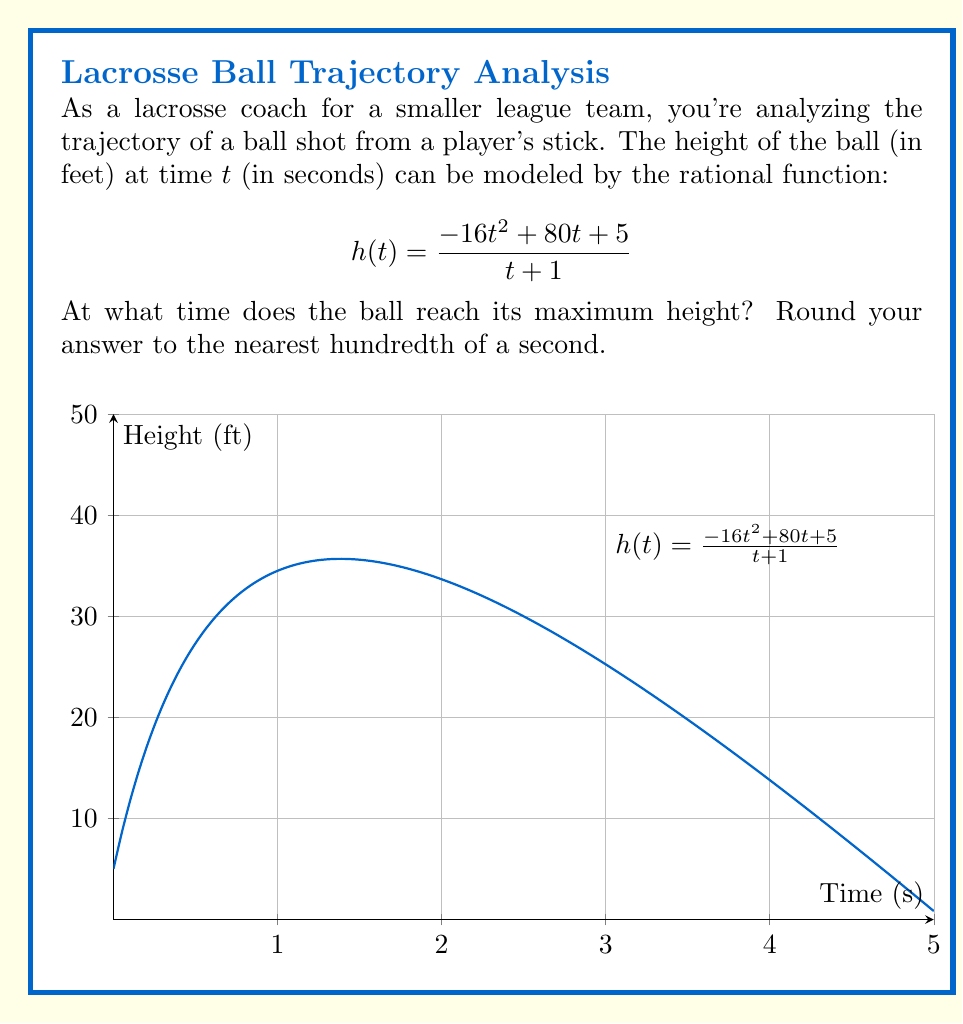Solve this math problem. To find the maximum height of the ball, we need to determine where the derivative of h(t) equals zero.

1) First, let's find h'(t) using the quotient rule:
   $$h'(t) = \frac{(-32t + 80)(t + 1) - (-16t^2 + 80t + 5)(1)}{(t + 1)^2}$$

2) Simplify the numerator:
   $$h'(t) = \frac{-32t^2 - 32t + 80t + 80 + 16t^2 - 80t - 5}{(t + 1)^2}$$
   $$h'(t) = \frac{-16t^2 + 48t + 75}{(t + 1)^2}$$

3) Set h'(t) = 0 and solve for t:
   $$\frac{-16t^2 + 48t + 75}{(t + 1)^2} = 0$$

4) The denominator is always positive for real t, so we only need to solve:
   $$-16t^2 + 48t + 75 = 0$$

5) This is a quadratic equation. We can solve it using the quadratic formula:
   $$t = \frac{-b \pm \sqrt{b^2 - 4ac}}{2a}$$
   Where a = -16, b = 48, and c = 75

6) Plugging in these values:
   $$t = \frac{-48 \pm \sqrt{48^2 - 4(-16)(75)}}{2(-16)}$$
   $$t = \frac{-48 \pm \sqrt{2304 + 4800}}{-32}$$
   $$t = \frac{-48 \pm \sqrt{7104}}{-32}$$
   $$t = \frac{-48 \pm 84.28}{-32}$$

7) This gives us two solutions:
   $$t = \frac{-48 + 84.28}{-32} \approx 1.13$$
   $$t = \frac{-48 - 84.28}{-32} \approx 4.13$$

8) The smaller value, 1.13 seconds, corresponds to the maximum height, as the ball reaches its peak before falling back down.
Answer: 1.13 seconds 